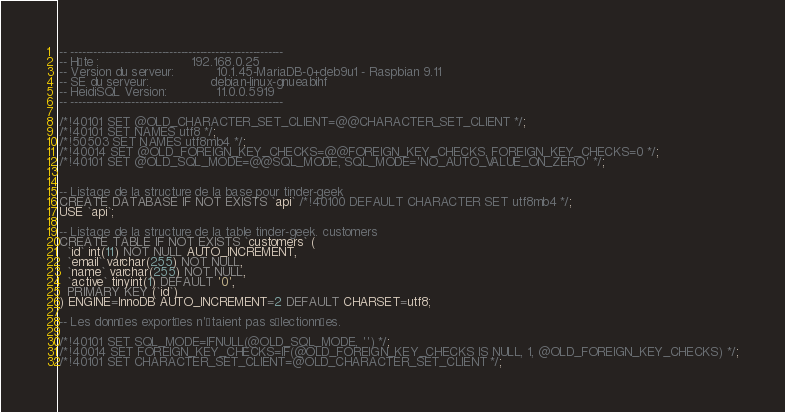Convert code to text. <code><loc_0><loc_0><loc_500><loc_500><_SQL_>-- --------------------------------------------------------
-- Hôte :                        192.168.0.25
-- Version du serveur:           10.1.45-MariaDB-0+deb9u1 - Raspbian 9.11
-- SE du serveur:                debian-linux-gnueabihf
-- HeidiSQL Version:             11.0.0.5919
-- --------------------------------------------------------

/*!40101 SET @OLD_CHARACTER_SET_CLIENT=@@CHARACTER_SET_CLIENT */;
/*!40101 SET NAMES utf8 */;
/*!50503 SET NAMES utf8mb4 */;
/*!40014 SET @OLD_FOREIGN_KEY_CHECKS=@@FOREIGN_KEY_CHECKS, FOREIGN_KEY_CHECKS=0 */;
/*!40101 SET @OLD_SQL_MODE=@@SQL_MODE, SQL_MODE='NO_AUTO_VALUE_ON_ZERO' */;


-- Listage de la structure de la base pour tinder-geek
CREATE DATABASE IF NOT EXISTS `api` /*!40100 DEFAULT CHARACTER SET utf8mb4 */;
USE `api`;

-- Listage de la structure de la table tinder-geek. customers
CREATE TABLE IF NOT EXISTS `customers` (
  `id` int(11) NOT NULL AUTO_INCREMENT,
  `email` varchar(255) NOT NULL,
  `name` varchar(255) NOT NULL,
  `active` tinyint(1) DEFAULT '0',
  PRIMARY KEY (`id`)
) ENGINE=InnoDB AUTO_INCREMENT=2 DEFAULT CHARSET=utf8;

-- Les données exportées n'étaient pas sélectionnées.

/*!40101 SET SQL_MODE=IFNULL(@OLD_SQL_MODE, '') */;
/*!40014 SET FOREIGN_KEY_CHECKS=IF(@OLD_FOREIGN_KEY_CHECKS IS NULL, 1, @OLD_FOREIGN_KEY_CHECKS) */;
/*!40101 SET CHARACTER_SET_CLIENT=@OLD_CHARACTER_SET_CLIENT */;
</code> 